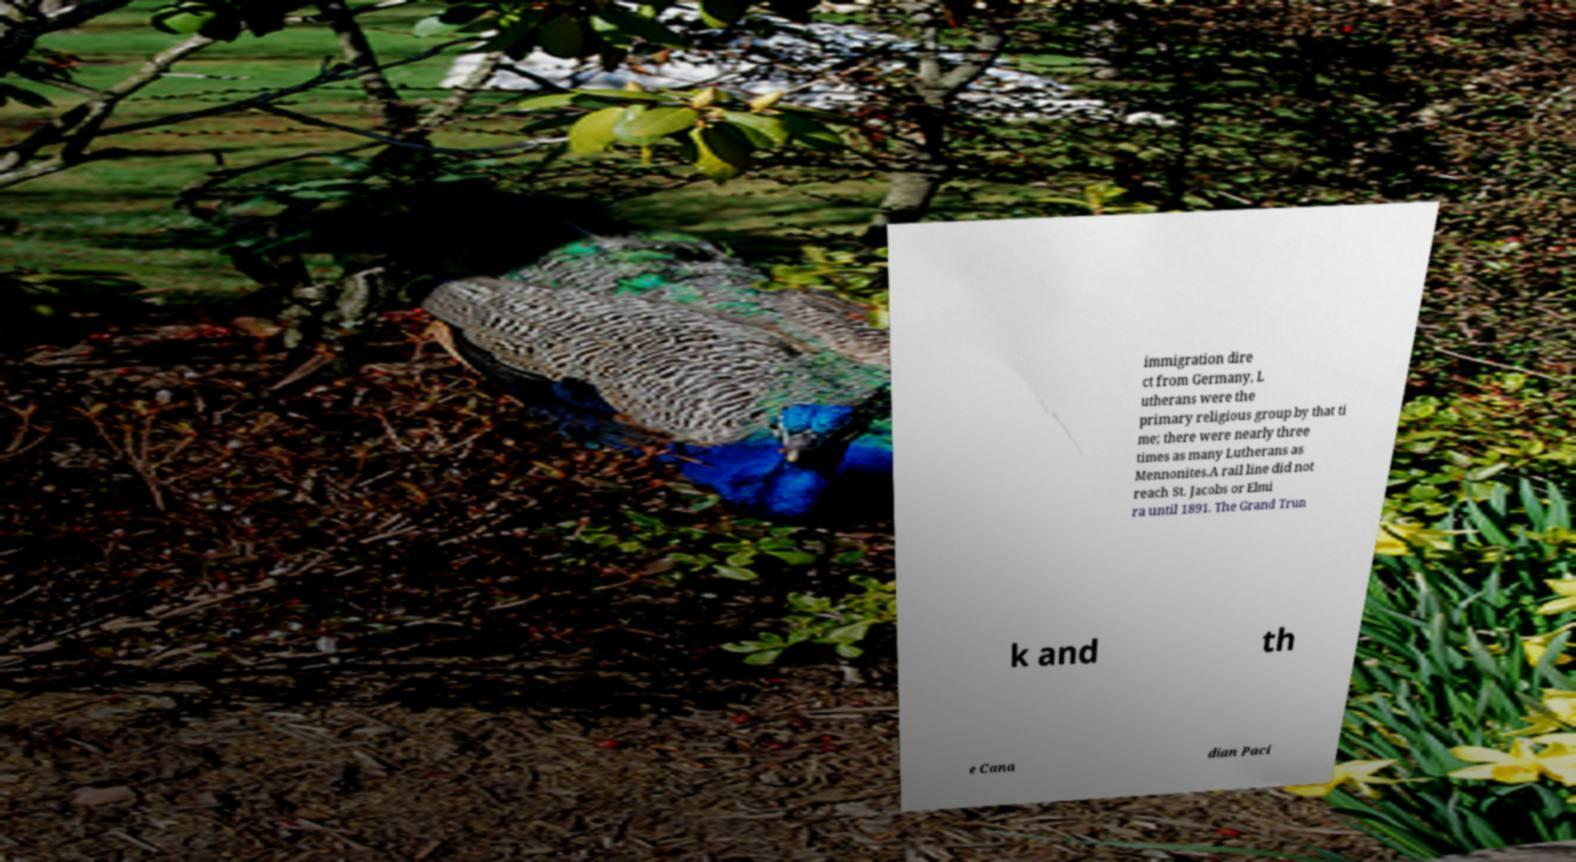Can you read and provide the text displayed in the image?This photo seems to have some interesting text. Can you extract and type it out for me? immigration dire ct from Germany, L utherans were the primary religious group by that ti me; there were nearly three times as many Lutherans as Mennonites.A rail line did not reach St. Jacobs or Elmi ra until 1891. The Grand Trun k and th e Cana dian Paci 